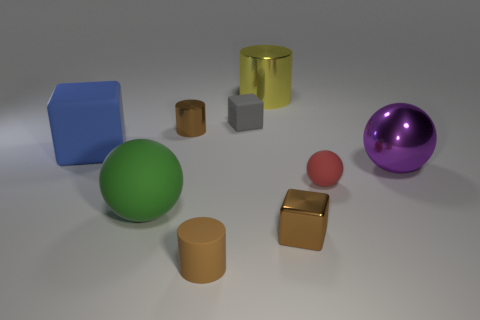Subtract 1 blocks. How many blocks are left? 2 Add 1 blue metallic cylinders. How many objects exist? 10 Subtract all cylinders. How many objects are left? 6 Add 2 green cylinders. How many green cylinders exist? 2 Subtract 0 gray balls. How many objects are left? 9 Subtract all large metal balls. Subtract all cubes. How many objects are left? 5 Add 5 tiny metallic blocks. How many tiny metallic blocks are left? 6 